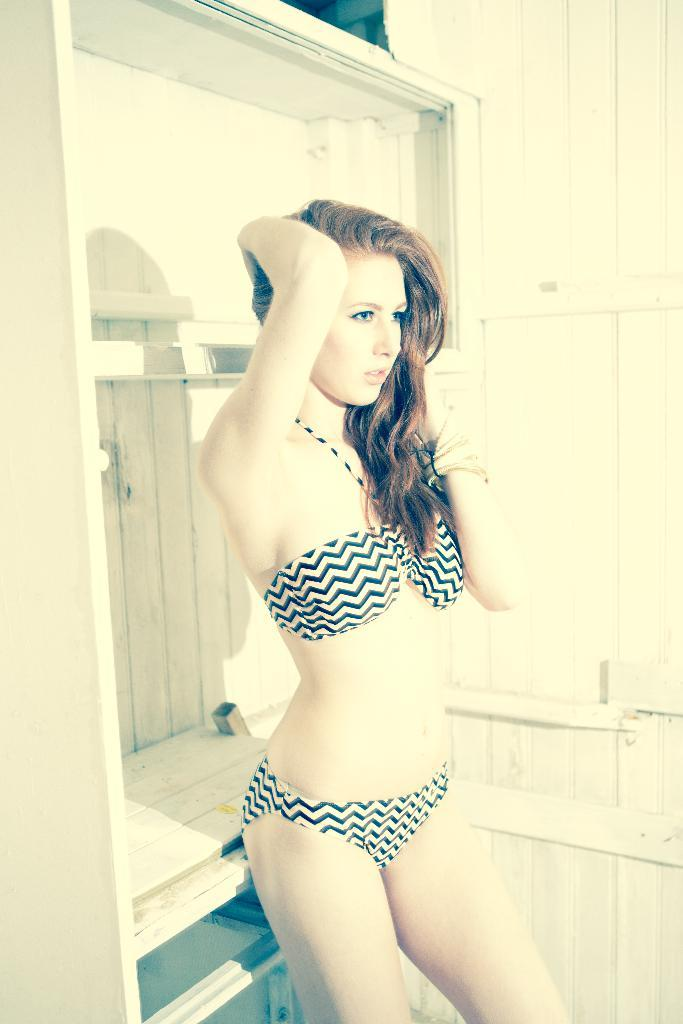Who is the main subject in the picture? There is a woman in the middle of the picture. What can be seen in the background of the picture? There is a wooden wall in the background of the picture. What is the name of the woman in the picture? The provided facts do not mention the name of the woman, so we cannot determine her name from the image. 